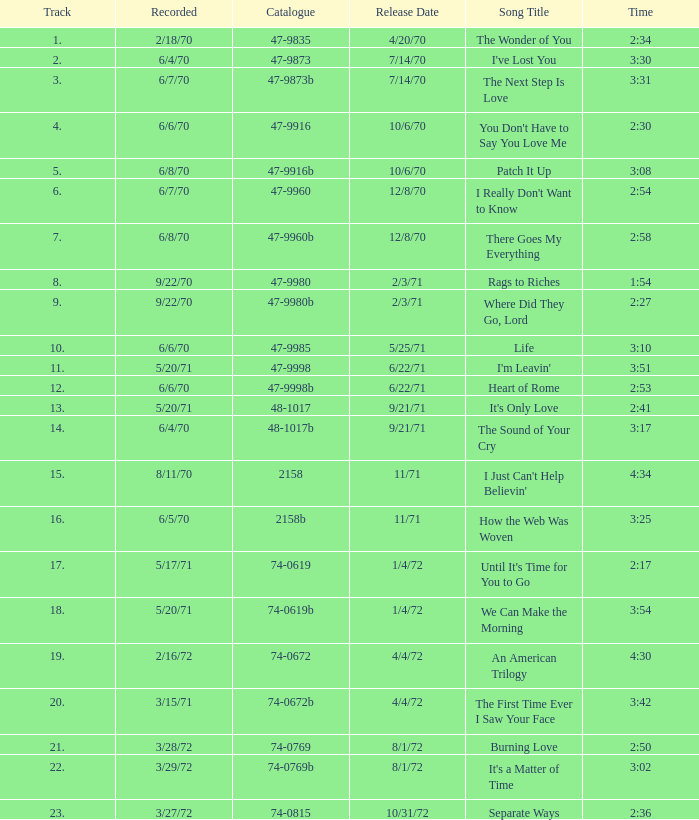Which track holds the highest position for burning love? 21.0. 